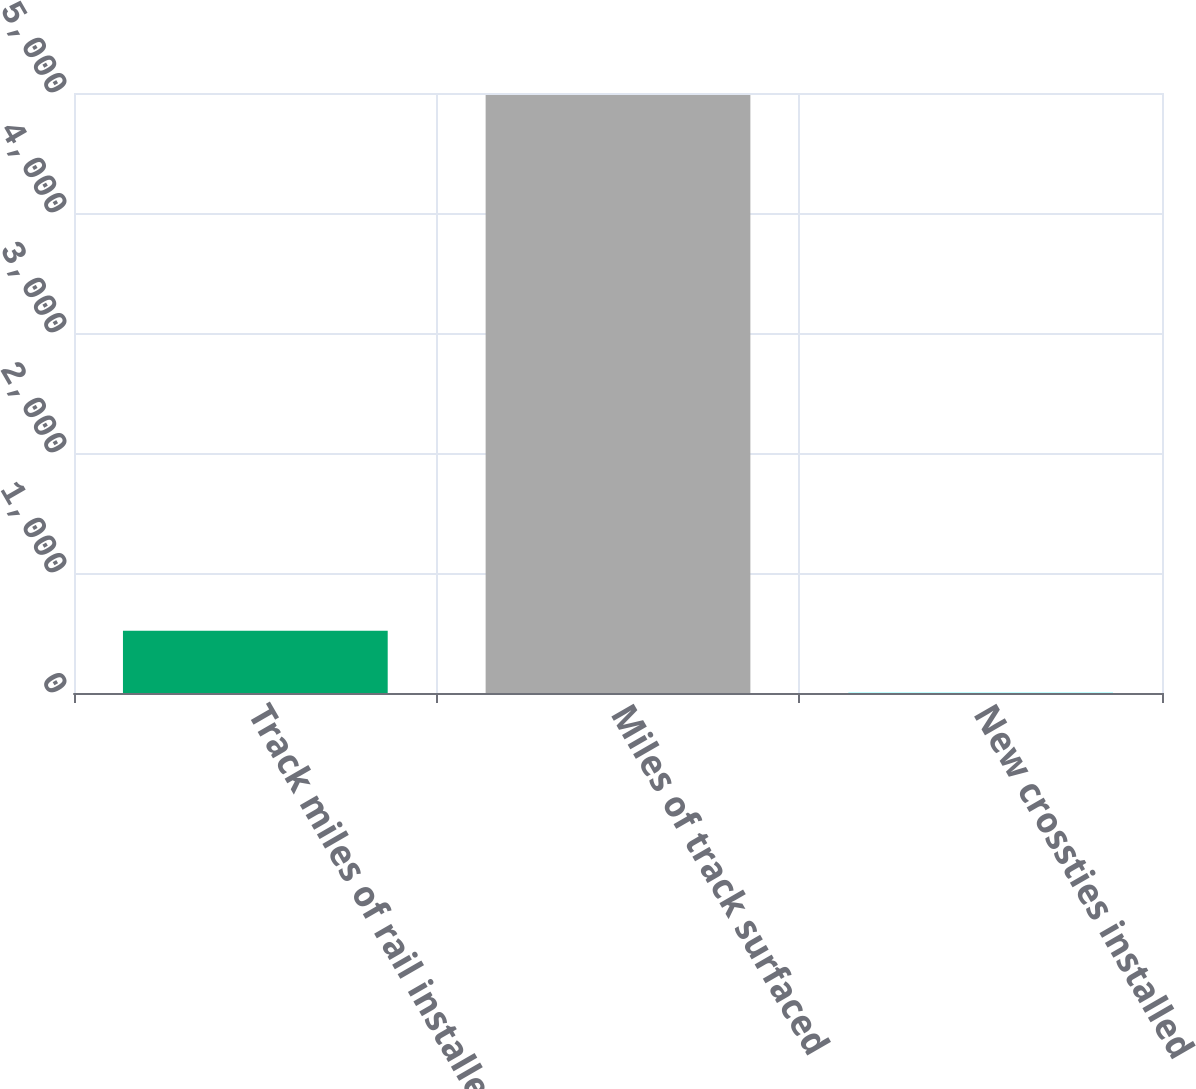Convert chart to OTSL. <chart><loc_0><loc_0><loc_500><loc_500><bar_chart><fcel>Track miles of rail installed<fcel>Miles of track surfaced<fcel>New crossties installed<nl><fcel>518<fcel>4984<fcel>2.3<nl></chart> 